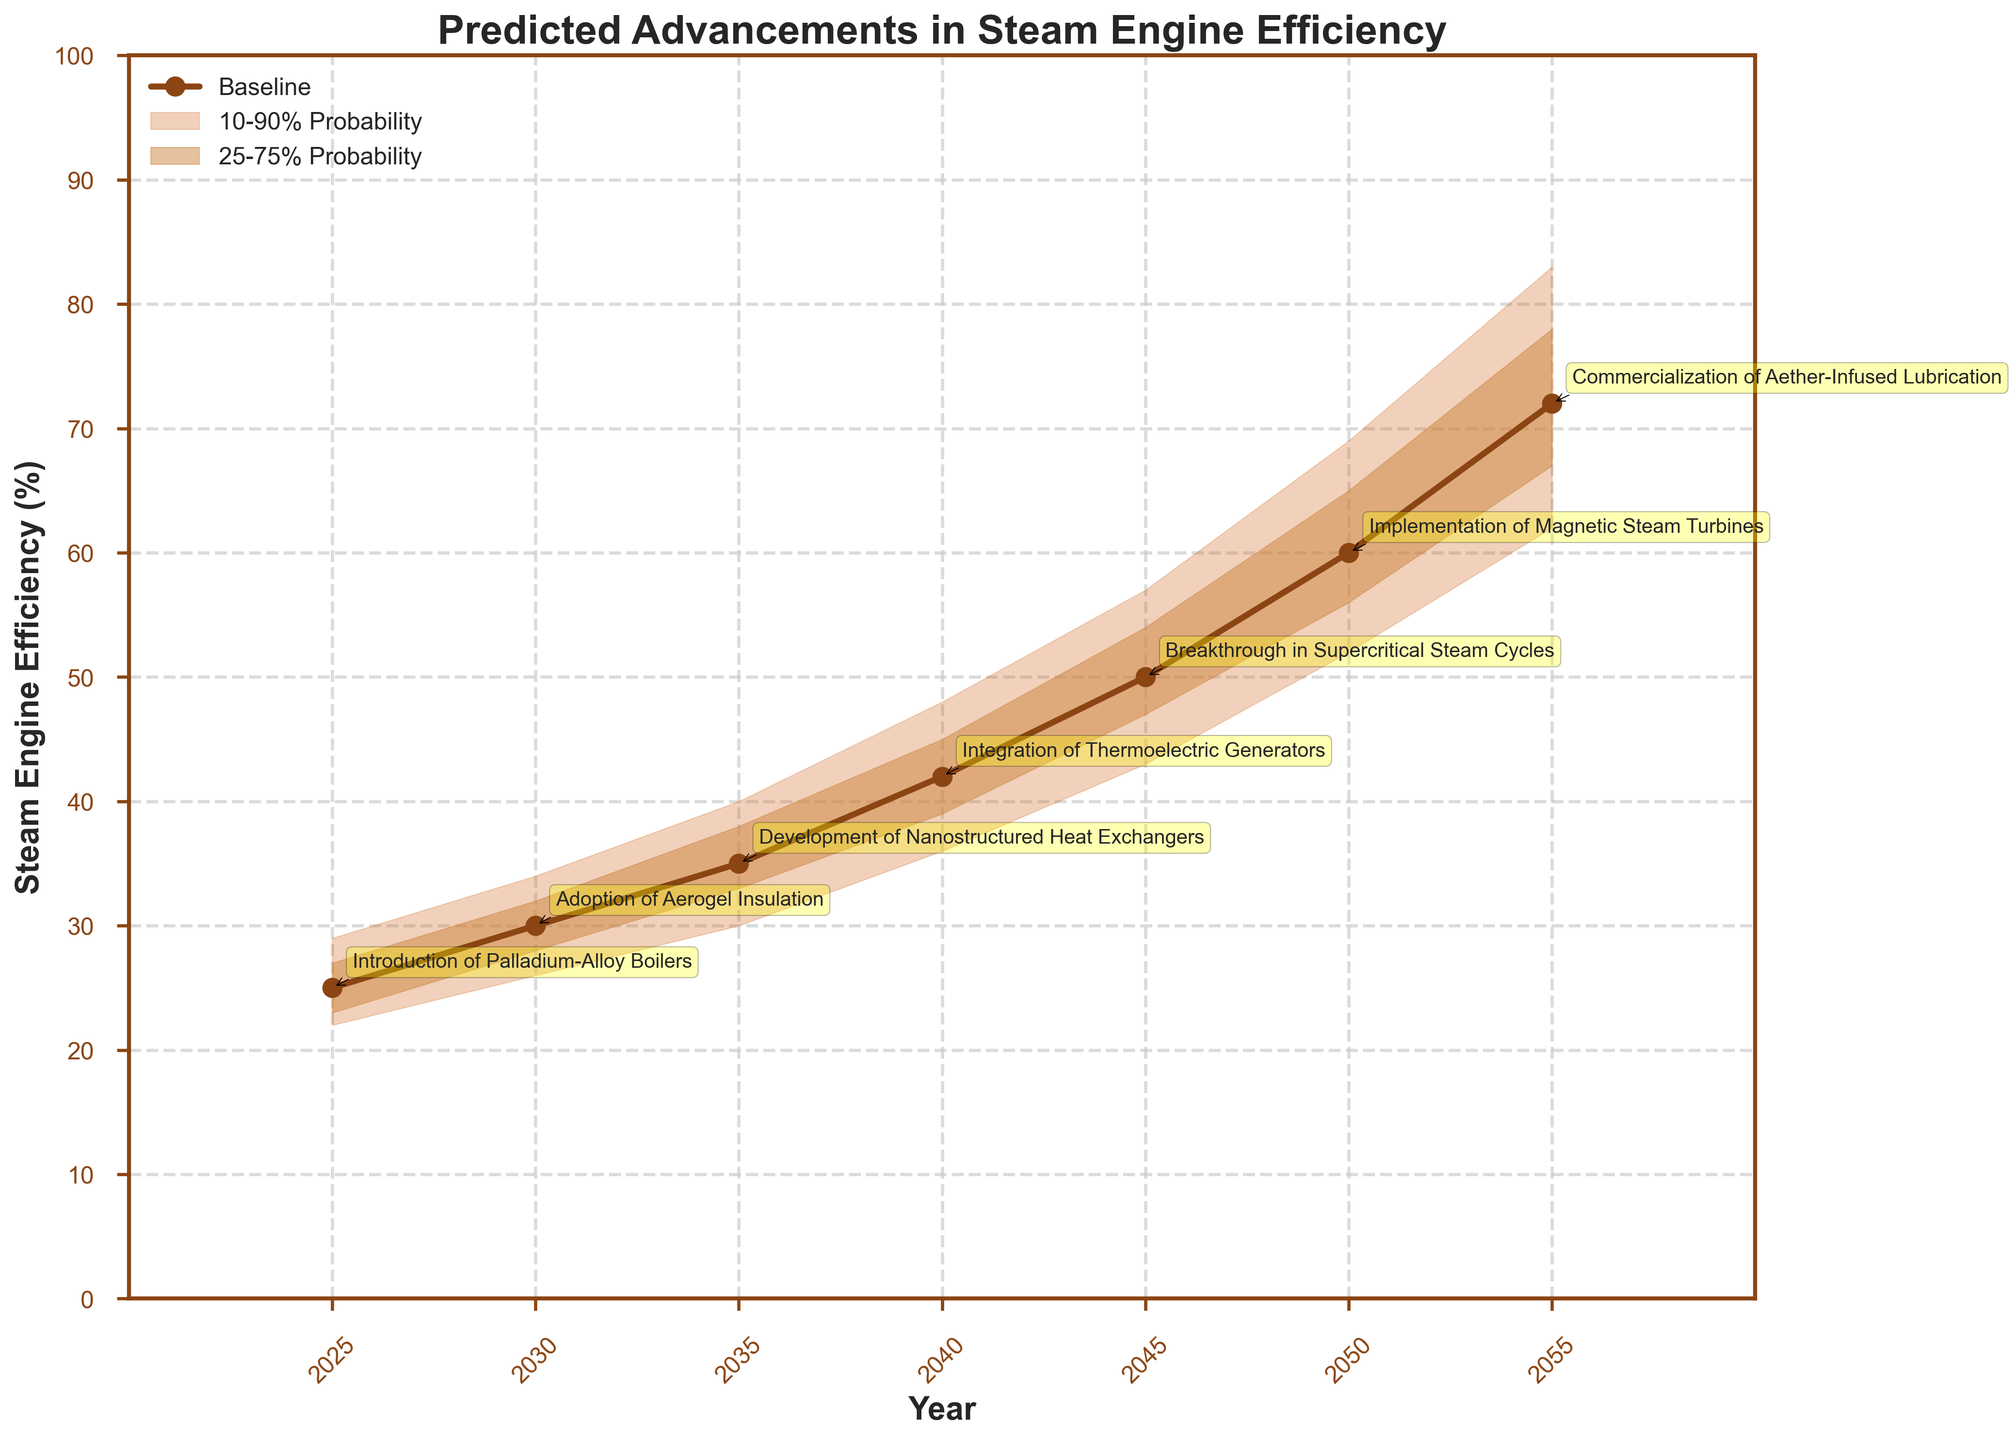What is the title of the figure? The title is shown at the top of the figure in bold letters. It is the first element you would see.
Answer: Predicted Advancements in Steam Engine Efficiency What is the expected baseline efficiency of steam engines in 2035? Locate the year 2035 on the x-axis and follow it to the baseline curve, then read the corresponding y-axis value.
Answer: 35% What is the range of efficiency predicted for the year 2040, between the 25th and 75th percentiles? Find the year 2040, then look at the shaded area between the LowP25 and HighP75 curves for that year to determine the values on the y-axis.
Answer: 39% to 45% Which year is associated with the introduction of Nanostructured Heat Exchangers? Look for the text box annotations pointing to the baseline curve indicating the events. Find the one labeled "Development of Nanostructured Heat Exchangers".
Answer: 2035 Between which two years does the largest increase in baseline efficiency occur? Examine the slope of the baseline curve between each pair of consecutive years and identify the pair with the steepest increase.
Answer: 2045 to 2050 What is the high probability (90th percentile) of efficiency expected by 2050? Locate the year 2050 on the x-axis and follow it up to the HighP90 curve, then read the corresponding y-axis value.
Answer: 69% By how many percentage points does the baseline efficiency increase from 2025 to 2055? Subtract the baseline efficiency in 2025 from that in 2055 (72% - 25%).
Answer: 47 Which event corresponds to the smallest increase in baseline efficiency from the previous milestone? Compare the change in baseline efficiency for each event by subtracting the previous year's baseline from the current year's baseline.
Answer: Introduction of Palladium-Alloy Boilers Which year predicts the start of the integration of Thermoelectric Generators? Look for the annotation pointing to the baseline curve labeled "Integration of Thermoelectric Generators".
Answer: 2040 How does the 10-90% confidence interval for efficiency change over time? Observe the shading between the LowP10 and HighP90 curves from 2025 to 2055. Note whether it narrows, widens, or stays the same.
Answer: Widens, then narrows on average 